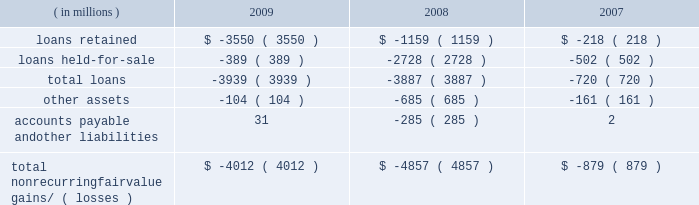Notes to consolidated financial statements jpmorgan chase & co./2009 annual report 168 nonrecurring fair value changes the table presents the total change in value of financial instruments for which a fair value adjustment has been included in the consolidated statements of income for the years ended december 31 , 2009 , 2008 and 2007 , related to financial instru- ments held at these dates .
Year ended december 31 .
Accounts payable and other liabilities 31 ( 285 ) 2 total nonrecurring fair value gains/ ( losses ) $ ( 4012 ) $ ( 4857 ) $ ( 879 ) in the above table , loans predominantly include : ( 1 ) write-downs of delinquent mortgage and home equity loans where impairment is based on the fair value of the underlying collateral ; and ( 2 ) the change in fair value for leveraged lending loans carried on the consolidated balance sheets at the lower of cost or fair value .
Accounts payable and other liabilities predominantly include the change in fair value for unfunded lending-related commitments within the leveraged lending portfolio .
Level 3 analysis level 3 assets ( including assets measured at fair value on a nonre- curring basis ) were 6% ( 6 % ) of total firm assets at both december 31 , 2009 and 2008 .
Level 3 assets were $ 130.4 billion at december 31 , 2009 , reflecting a decrease of $ 7.3 billion in 2009 , due to the following : 2022 a net decrease of $ 6.3 billion in gross derivative receivables , predominantly driven by the tightening of credit spreads .
Offset- ting a portion of the decrease were net transfers into level 3 dur- ing the year , most notably a transfer into level 3 of $ 41.3 billion of structured credit derivative receivables , and a transfer out of level 3 of $ 17.7 billion of single-name cds on abs .
The fair value of the receivables transferred into level 3 during the year was $ 22.1 billion at december 31 , 2009 .
The fair value of struc- tured credit derivative payables with a similar underlying risk profile to the previously noted receivables , that are also classified in level 3 , was $ 12.5 billion at december 31 , 2009 .
These de- rivatives payables offset the receivables , as they are modeled and valued the same way with the same parameters and inputs as the assets .
2022 a net decrease of $ 3.5 billion in loans , predominantly driven by sales of leveraged loans and transfers of similar loans to level 2 , due to increased price transparency for such assets .
Leveraged loans are typically classified as held-for-sale and measured at the lower of cost or fair value and , therefore , included in the nonre- curring fair value assets .
2022 a net decrease of $ 6.3 billion in trading assets 2013 debt and equity instruments , primarily in loans and residential- and commercial- mbs , principally driven by sales and markdowns , and by sales and unwinds of structured transactions with hedge funds .
The declines were partially offset by a transfer from level 2 to level 3 of certain structured notes reflecting lower liquidity and less pricing ob- servability , and also increases in the fair value of other abs .
2022 a net increase of $ 6.1 billion in msrs , due to increases in the fair value of the asset , related primarily to market interest rate and other changes affecting the firm's estimate of future pre- payments , as well as sales in rfs of originated loans for which servicing rights were retained .
These increases were offset par- tially by servicing portfolio runoff .
2022 a net increase of $ 1.9 billion in accrued interest and accounts receivable related to increases in subordinated retained interests from the firm 2019s credit card securitization activities .
Gains and losses gains and losses included in the tables for 2009 and 2008 included : 2022 $ 11.4 billion of net losses on derivatives , primarily related to the tightening of credit spreads .
2022 net losses on trading 2013debt and equity instruments of $ 671 million , consisting of $ 2.1 billion of losses , primarily related to residential and commercial loans and mbs , principally driven by markdowns and sales , partially offset by gains of $ 1.4 billion , reflecting increases in the fair value of other abs .
( for a further discussion of the gains and losses on mortgage-related expo- sures , inclusive of risk management activities , see the 201cmort- gage-related exposures carried at fair value 201d discussion below. ) 2022 $ 5.8 billion of gains on msrs .
2022 $ 1.4 billion of losses related to structured note liabilities , pre- dominantly due to volatility in the equity markets .
2022 losses on trading-debt and equity instruments of approximately $ 12.8 billion , principally from mortgage-related transactions and auction-rate securities .
2022 losses of $ 6.9 billion on msrs .
2022 losses of approximately $ 3.9 billion on leveraged loans .
2022 net gains of $ 4.6 billion related to derivatives , principally due to changes in credit spreads and rate curves .
2022 gains of $ 4.5 billion related to structured notes , principally due to significant volatility in the fixed income , commodities and eq- uity markets .
2022 private equity losses of $ 638 million .
For further information on changes in the fair value of the msrs , see note 17 on pages 223 2013224 of this annual report. .
How much of the change in level 3 assets was due to the net decrease in derivative receivables due to the tightening of credit spreads? 
Computations: (6.3 / 7.3)
Answer: 0.86301. 